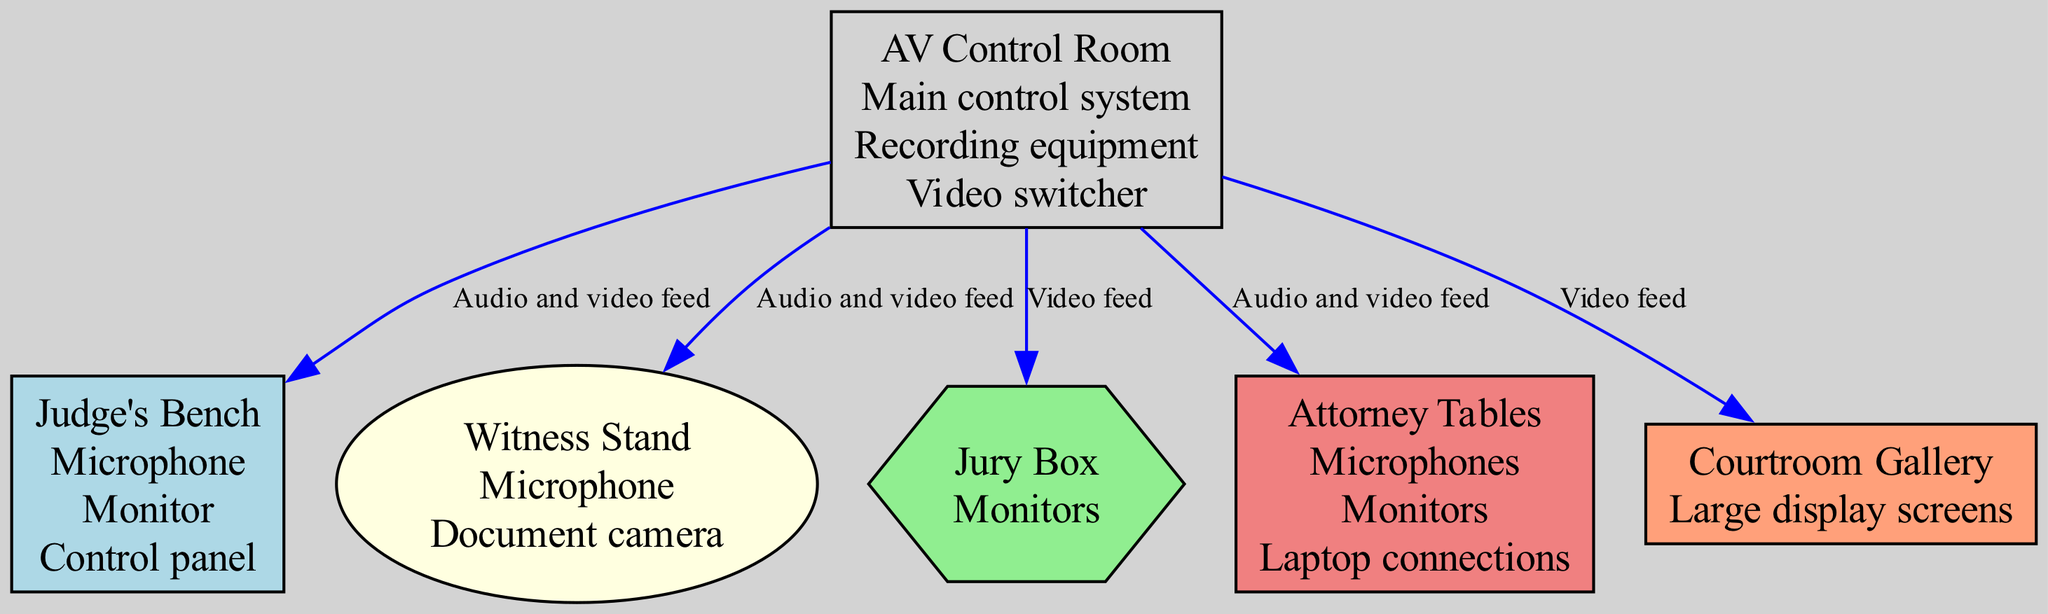What is the main control system location? The main control system is located in the AV Control Room, as indicated in the diagram where it is listed under the equipment for that node.
Answer: AV Control Room How many types of audio equipment are in the courtroom? By examining the nodes and identifying audio-related equipment, we find microphones listed for Judge's Bench, Witness Stand, and Attorney Tables. Thus, there are three types.
Answer: Three Which node is connected to the courtroom gallery? The connection flows from the AV Control Room to the courtroom gallery as shown by an edge in the diagram labeled with "Video feed."
Answer: Courtroom Gallery How many monitors are present in the attorney tables? The attorney tables are equipped with monitors according to the node description, indicating one type of equipment, but the specific number is not listed in the data so we assume one type.
Answer: Monitors What kind of feed does the AV Control Room provide to the jury box? The AV Control Room provides a video feed to the jury box, stated directly in the edge connecting these two nodes.
Answer: Video feed Which two areas receive an audio and video feed from the AV Control Room? The edge from the AV Control Room indicates that both the Judge's Bench and the Attorney Tables receive both audio and video feeds as specified in the labels.
Answer: Judge's Bench, Attorney Tables What equipment is listed for the witness stand? The witness stand lists a microphone and a document camera as part of its equipment, which are clearly labeled in the corresponding node.
Answer: Microphone, Document camera How many nodes receive audio feeds? By examining the edges related to audio feeds, we see that both the Judge's Bench and Attorney Tables are the nodes that receive audio feeds from the AV Control Room. This totals two nodes.
Answer: Two What color represents the jury box in the diagram? The jury box is represented in light green color per the color assignment in the diagram for that specific node.
Answer: Light green 